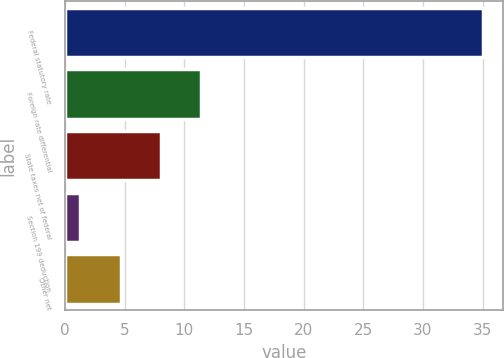Convert chart to OTSL. <chart><loc_0><loc_0><loc_500><loc_500><bar_chart><fcel>Federal statutory rate<fcel>Foreign rate differential<fcel>State taxes net of federal<fcel>Section 199 deduction<fcel>Other net<nl><fcel>35<fcel>11.41<fcel>8.04<fcel>1.3<fcel>4.67<nl></chart> 